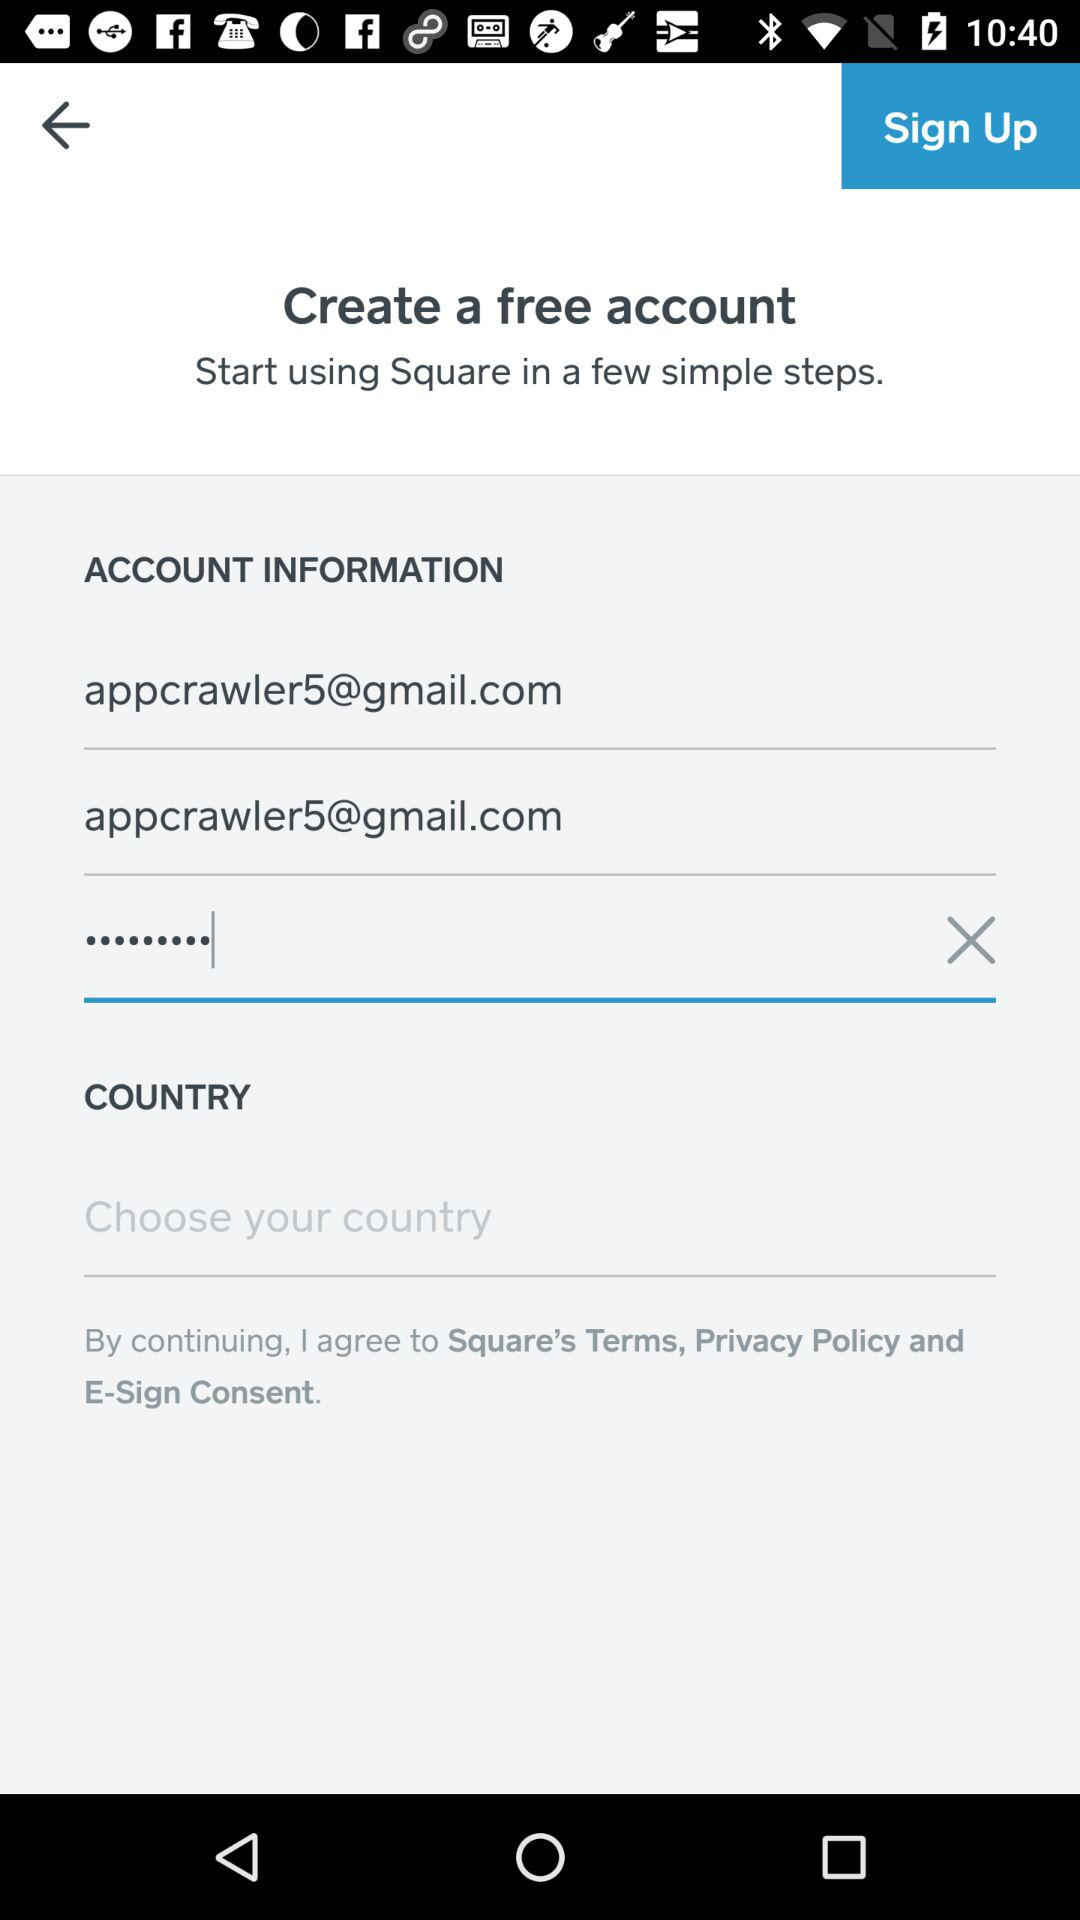How many text inputs have an email address in them?
Answer the question using a single word or phrase. 2 